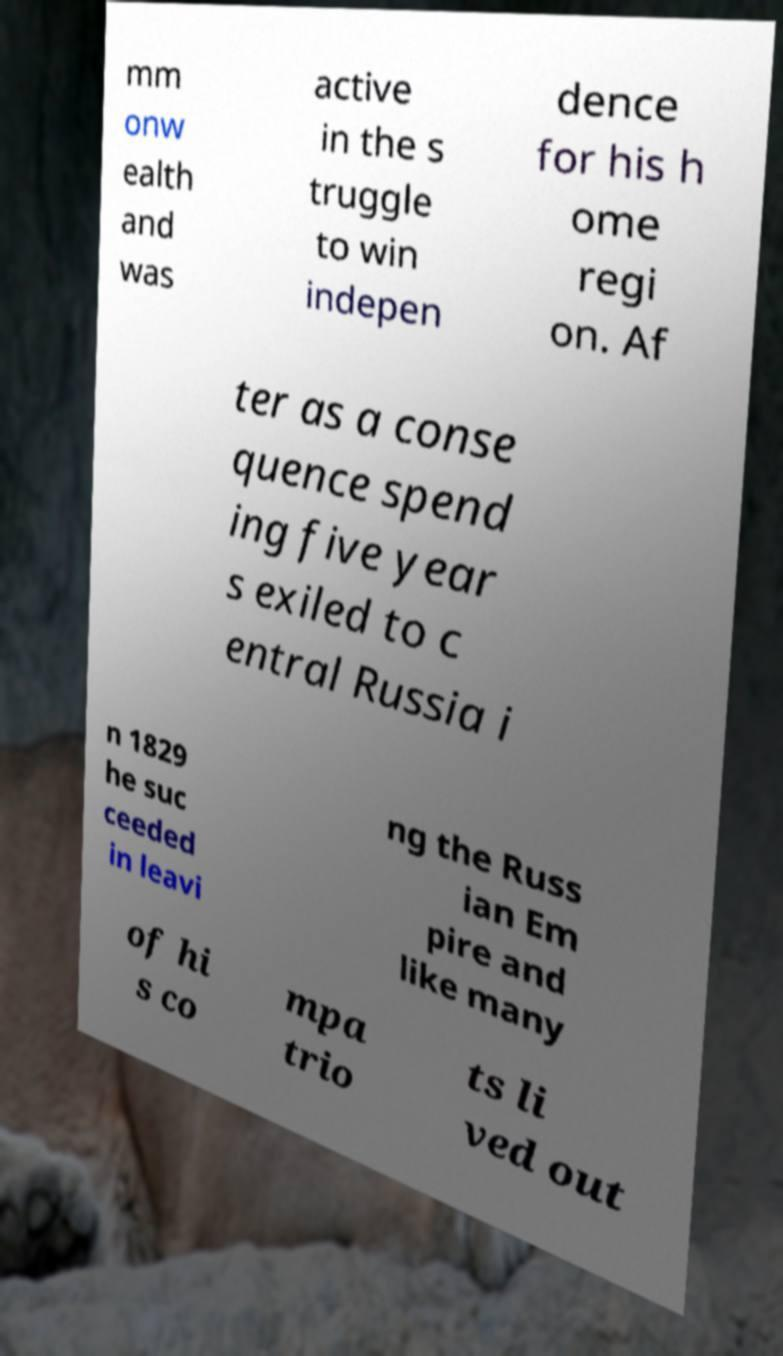Please identify and transcribe the text found in this image. mm onw ealth and was active in the s truggle to win indepen dence for his h ome regi on. Af ter as a conse quence spend ing five year s exiled to c entral Russia i n 1829 he suc ceeded in leavi ng the Russ ian Em pire and like many of hi s co mpa trio ts li ved out 